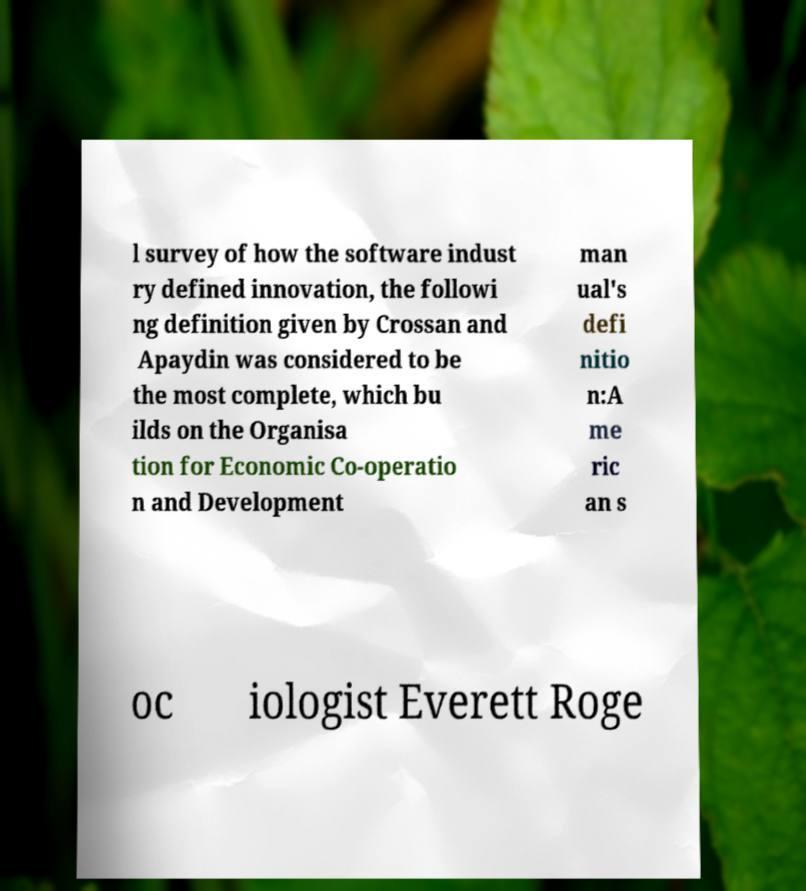Can you accurately transcribe the text from the provided image for me? l survey of how the software indust ry defined innovation, the followi ng definition given by Crossan and Apaydin was considered to be the most complete, which bu ilds on the Organisa tion for Economic Co-operatio n and Development man ual's defi nitio n:A me ric an s oc iologist Everett Roge 